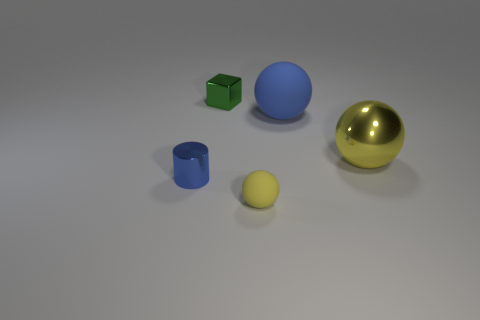Subtract all large spheres. How many spheres are left? 1 Subtract all yellow spheres. How many spheres are left? 1 Add 1 large brown objects. How many objects exist? 6 Subtract 0 brown cubes. How many objects are left? 5 Subtract all balls. How many objects are left? 2 Subtract all yellow balls. Subtract all yellow cylinders. How many balls are left? 1 Subtract all cyan cylinders. How many blue balls are left? 1 Subtract all green things. Subtract all large yellow balls. How many objects are left? 3 Add 2 blue spheres. How many blue spheres are left? 3 Add 5 small blue cylinders. How many small blue cylinders exist? 6 